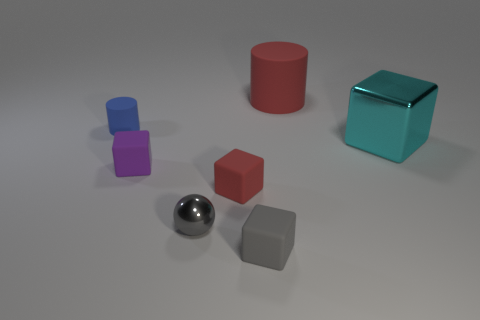Are there any gray things of the same shape as the large red object?
Your answer should be compact. No. What material is the gray cube?
Offer a very short reply. Rubber. There is a shiny block; are there any tiny rubber cubes behind it?
Offer a terse response. No. Is the shape of the blue matte object the same as the big red matte object?
Your answer should be very brief. Yes. What number of other things are there of the same size as the ball?
Make the answer very short. 4. What number of things are small rubber blocks right of the small gray metal sphere or small gray blocks?
Ensure brevity in your answer.  2. What color is the tiny metal object?
Provide a short and direct response. Gray. What material is the object left of the small purple cube?
Give a very brief answer. Rubber. There is a big matte object; does it have the same shape as the tiny rubber thing behind the small purple rubber cube?
Keep it short and to the point. Yes. Are there more rubber objects than tiny purple blocks?
Ensure brevity in your answer.  Yes. 